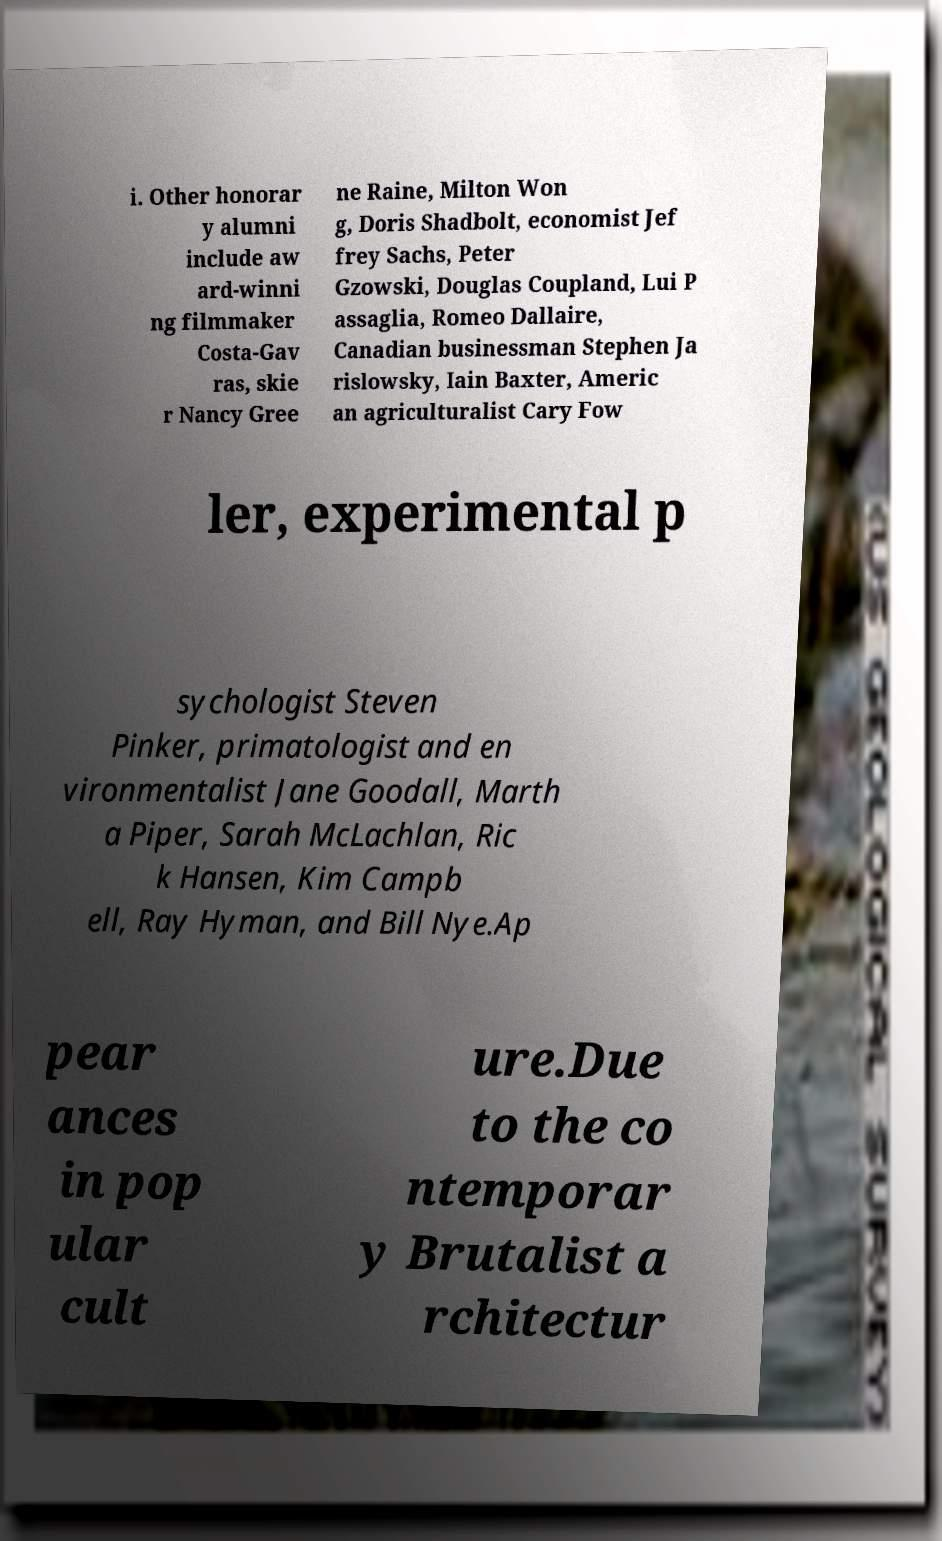Could you extract and type out the text from this image? i. Other honorar y alumni include aw ard-winni ng filmmaker Costa-Gav ras, skie r Nancy Gree ne Raine, Milton Won g, Doris Shadbolt, economist Jef frey Sachs, Peter Gzowski, Douglas Coupland, Lui P assaglia, Romeo Dallaire, Canadian businessman Stephen Ja rislowsky, Iain Baxter, Americ an agriculturalist Cary Fow ler, experimental p sychologist Steven Pinker, primatologist and en vironmentalist Jane Goodall, Marth a Piper, Sarah McLachlan, Ric k Hansen, Kim Campb ell, Ray Hyman, and Bill Nye.Ap pear ances in pop ular cult ure.Due to the co ntemporar y Brutalist a rchitectur 